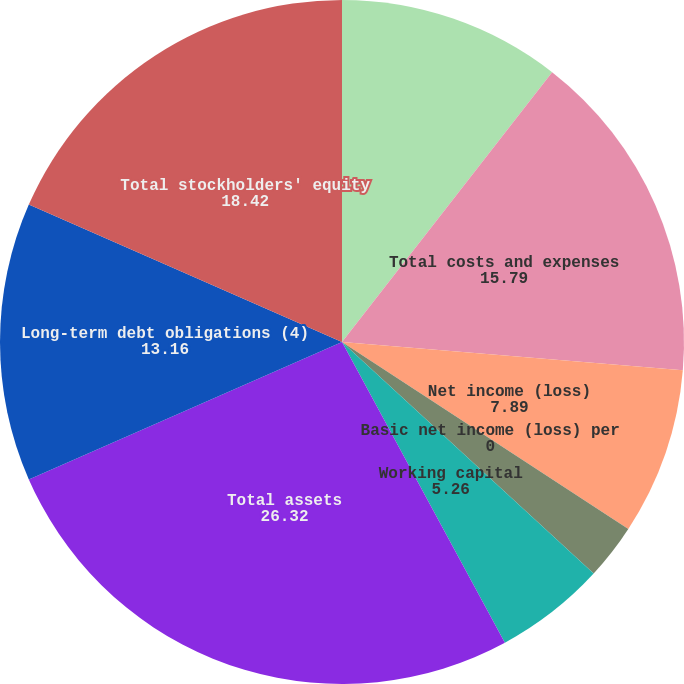Convert chart to OTSL. <chart><loc_0><loc_0><loc_500><loc_500><pie_chart><fcel>Total revenues<fcel>Total costs and expenses<fcel>Net income (loss)<fcel>Basic net income (loss) per<fcel>Diluted net income (loss) per<fcel>Working capital<fcel>Total assets<fcel>Long-term debt obligations (4)<fcel>Total stockholders' equity<nl><fcel>10.53%<fcel>15.79%<fcel>7.89%<fcel>0.0%<fcel>2.63%<fcel>5.26%<fcel>26.32%<fcel>13.16%<fcel>18.42%<nl></chart> 